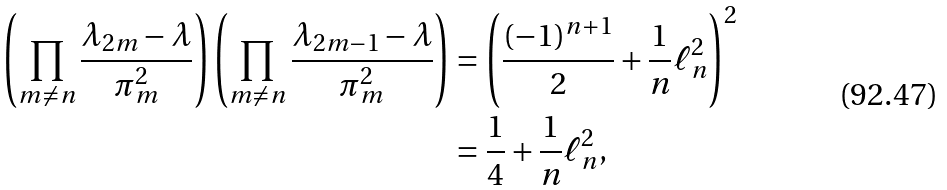Convert formula to latex. <formula><loc_0><loc_0><loc_500><loc_500>\left ( \prod _ { m \neq n } \frac { \lambda _ { 2 m } - \lambda } { \pi _ { m } ^ { 2 } } \right ) \left ( \prod _ { m \neq n } \frac { \lambda _ { 2 m - 1 } - \lambda } { \pi _ { m } ^ { 2 } } \right ) & = \left ( \frac { ( - 1 ) ^ { n + 1 } } { 2 } + \frac { 1 } { n } \ell ^ { 2 } _ { n } \right ) ^ { 2 } \\ & = \frac { 1 } { 4 } + \frac { 1 } { n } \ell ^ { 2 } _ { n } ,</formula> 